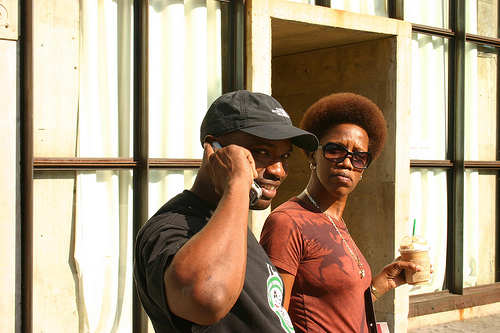What kind of environment are the people in? They are standing in front of a building with large windows and what appears to be a reflective metallic facade. The setting suggests an urban street scene, likely in a commercial or busy city area given the architectural features. 